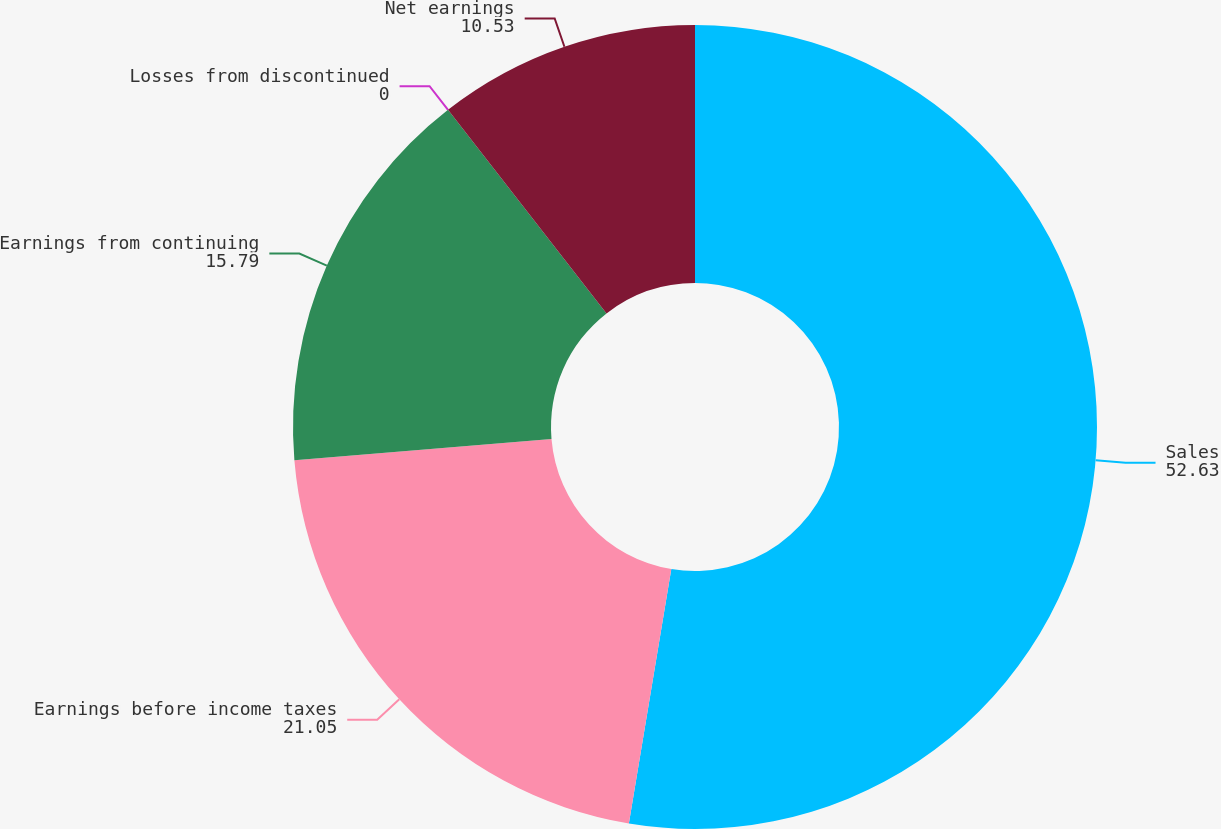Convert chart. <chart><loc_0><loc_0><loc_500><loc_500><pie_chart><fcel>Sales<fcel>Earnings before income taxes<fcel>Earnings from continuing<fcel>Losses from discontinued<fcel>Net earnings<nl><fcel>52.63%<fcel>21.05%<fcel>15.79%<fcel>0.0%<fcel>10.53%<nl></chart> 